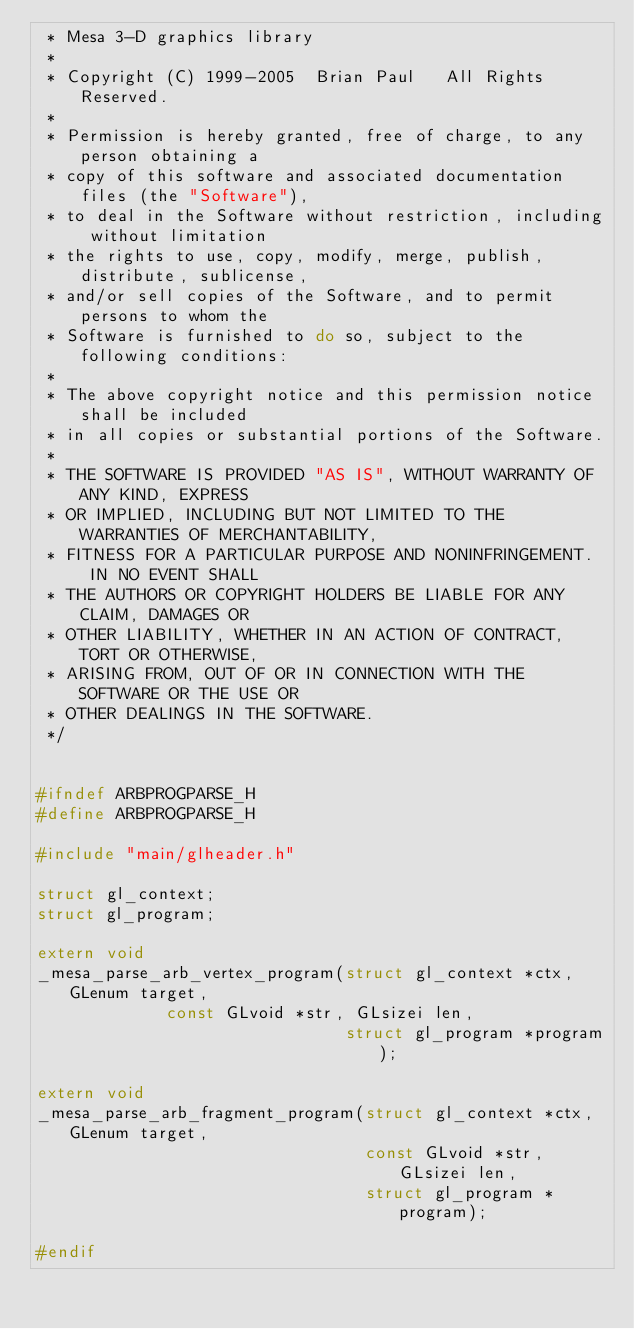Convert code to text. <code><loc_0><loc_0><loc_500><loc_500><_C_> * Mesa 3-D graphics library
 *
 * Copyright (C) 1999-2005  Brian Paul   All Rights Reserved.
 *
 * Permission is hereby granted, free of charge, to any person obtaining a
 * copy of this software and associated documentation files (the "Software"),
 * to deal in the Software without restriction, including without limitation
 * the rights to use, copy, modify, merge, publish, distribute, sublicense,
 * and/or sell copies of the Software, and to permit persons to whom the
 * Software is furnished to do so, subject to the following conditions:
 *
 * The above copyright notice and this permission notice shall be included
 * in all copies or substantial portions of the Software.
 *
 * THE SOFTWARE IS PROVIDED "AS IS", WITHOUT WARRANTY OF ANY KIND, EXPRESS
 * OR IMPLIED, INCLUDING BUT NOT LIMITED TO THE WARRANTIES OF MERCHANTABILITY,
 * FITNESS FOR A PARTICULAR PURPOSE AND NONINFRINGEMENT.  IN NO EVENT SHALL
 * THE AUTHORS OR COPYRIGHT HOLDERS BE LIABLE FOR ANY CLAIM, DAMAGES OR
 * OTHER LIABILITY, WHETHER IN AN ACTION OF CONTRACT, TORT OR OTHERWISE,
 * ARISING FROM, OUT OF OR IN CONNECTION WITH THE SOFTWARE OR THE USE OR
 * OTHER DEALINGS IN THE SOFTWARE.
 */


#ifndef ARBPROGPARSE_H
#define ARBPROGPARSE_H

#include "main/glheader.h"

struct gl_context;
struct gl_program;

extern void
_mesa_parse_arb_vertex_program(struct gl_context *ctx, GLenum target,
			       const GLvoid *str, GLsizei len,
                               struct gl_program *program);

extern void
_mesa_parse_arb_fragment_program(struct gl_context *ctx, GLenum target,
                                 const GLvoid *str, GLsizei len,
                                 struct gl_program *program);

#endif
</code> 